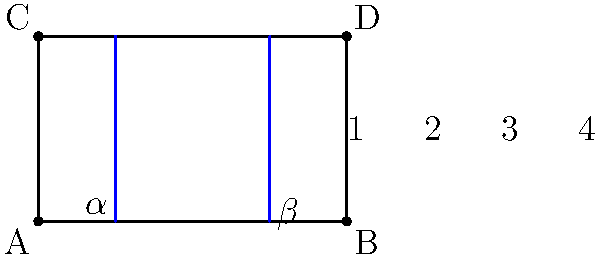In this diagram inspired by Rozzi's guitar fretboard, two "strings" (blue lines) intersect with the fretboard edges. If angle $\alpha = 70^\circ$ and angle $\beta = 80^\circ$, what is the sum of the measures of angles 2 and 3? Let's approach this step-by-step:

1) First, recall that when a line intersects two parallel lines, corresponding angles are equal. This means:
   - The angle at A is equal to $\alpha = 70^\circ$
   - The angle at B is equal to $\beta = 80^\circ$

2) In a quadrilateral, the sum of all interior angles is always $360^\circ$.

3) Let's call the angles in our quadrilateral:
   - Angle 1 = $70^\circ$ (corresponding to $\alpha$)
   - Angle 2 = x
   - Angle 3 = y
   - Angle 4 = $80^\circ$ (corresponding to $\beta$)

4) We can now set up an equation:
   $70^\circ + x + y + 80^\circ = 360^\circ$

5) Simplify:
   $150^\circ + x + y = 360^\circ$

6) Subtract $150^\circ$ from both sides:
   $x + y = 210^\circ$

7) The question asks for the sum of angles 2 and 3, which is exactly $x + y$.

Therefore, the sum of the measures of angles 2 and 3 is $210^\circ$.
Answer: $210^\circ$ 